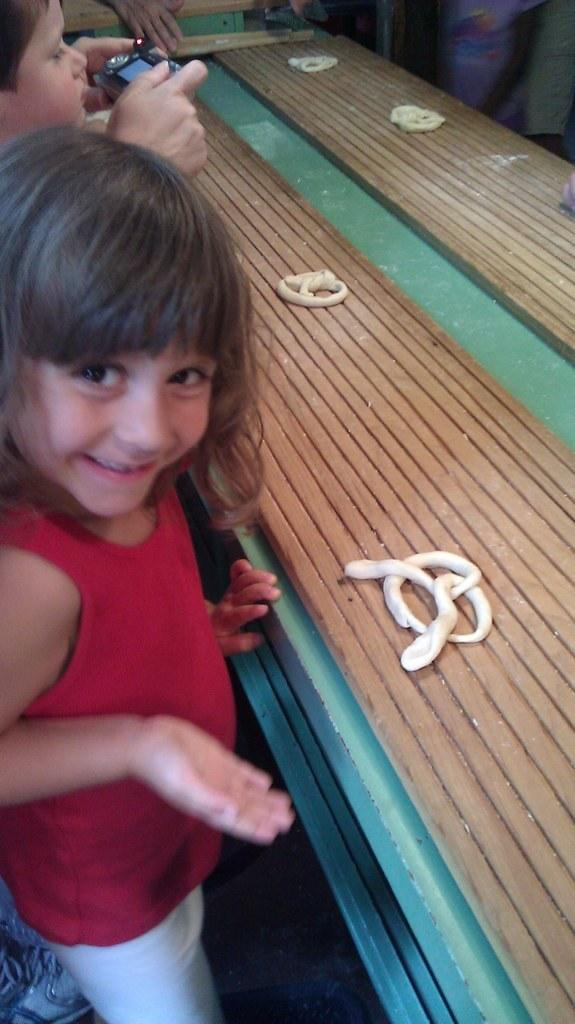What is the girl in the image doing? The girl is standing and smiling in the image. Where is the girl located in relation to the table? The girl is near a table in the image. What can be seen in the background of the image? There is a boy in the background of the image, and he is playing a video game. What is on the table in the image? There is an object on the table in the image. What type of mint is the girl chewing in the image? There is no mint present in the image, and the girl is not chewing anything. 